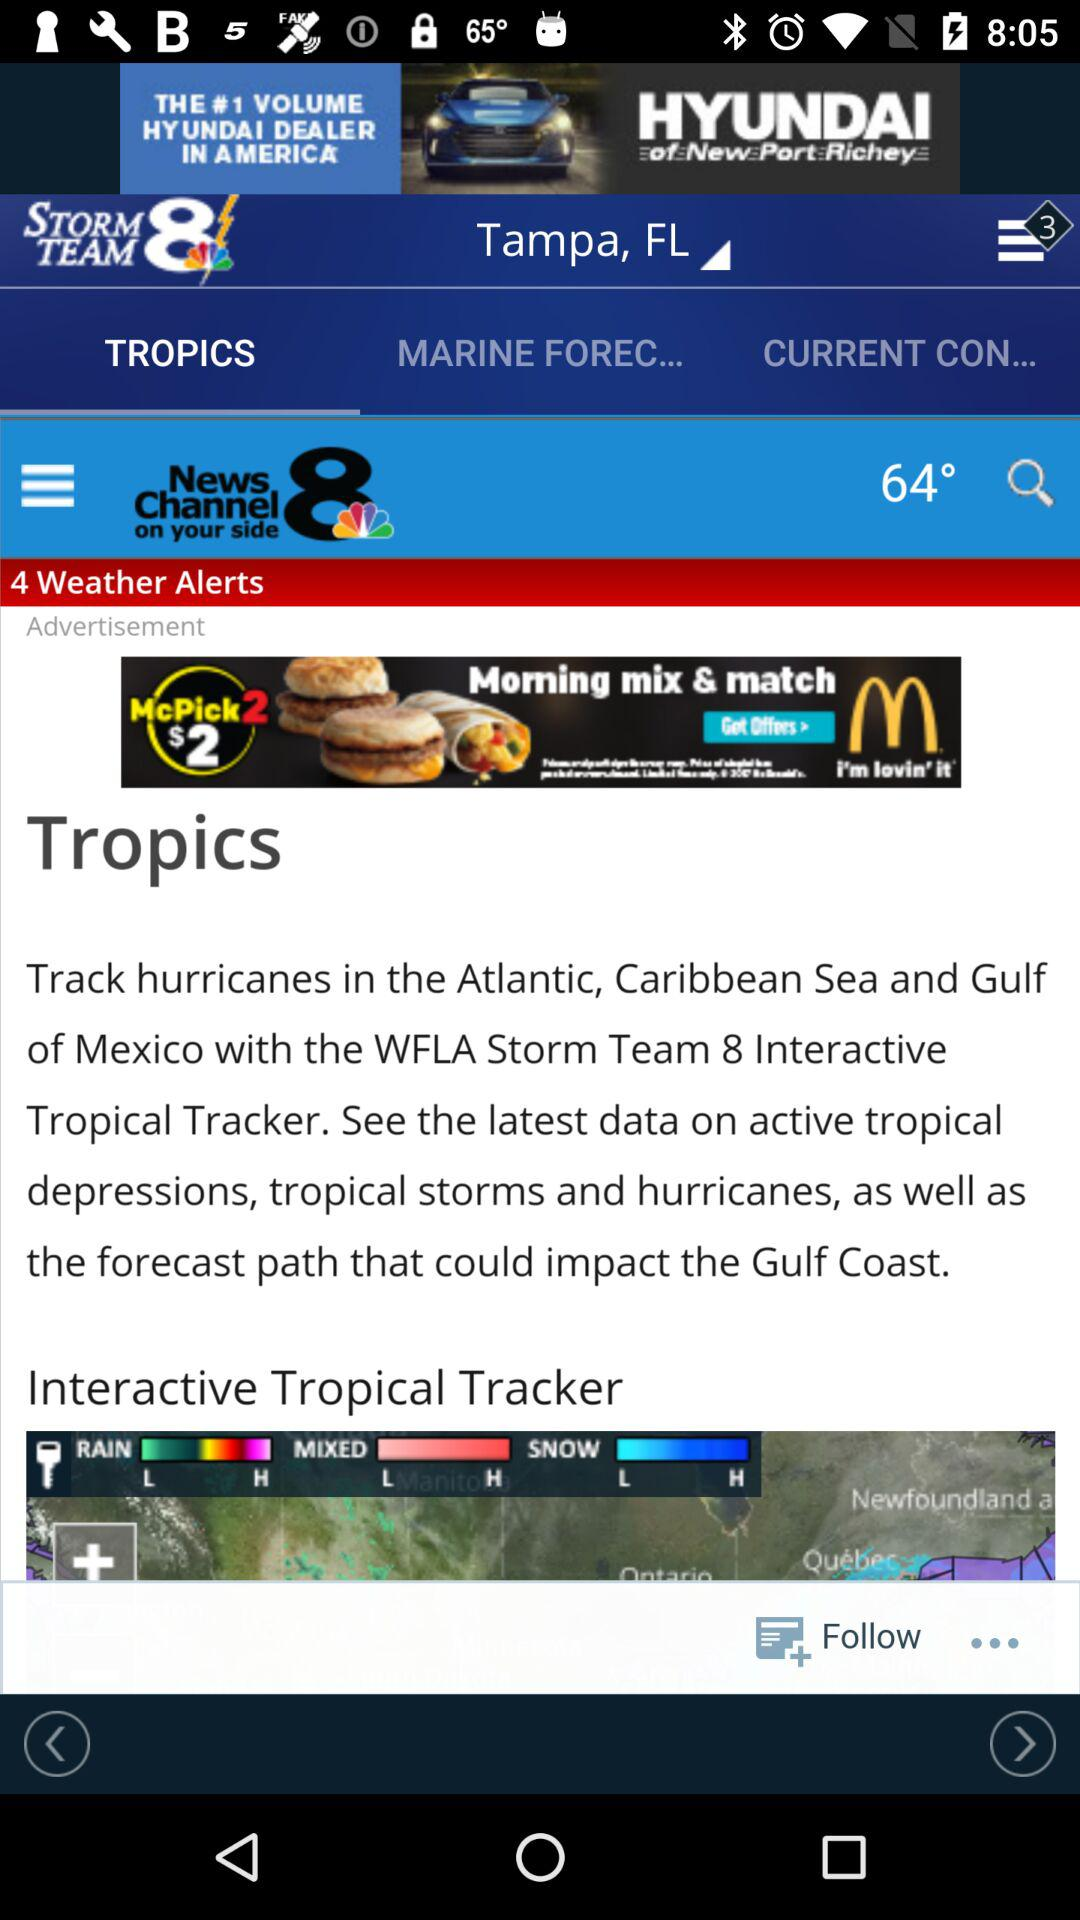Which tab is selected? The selected tab is "TROPICS". 